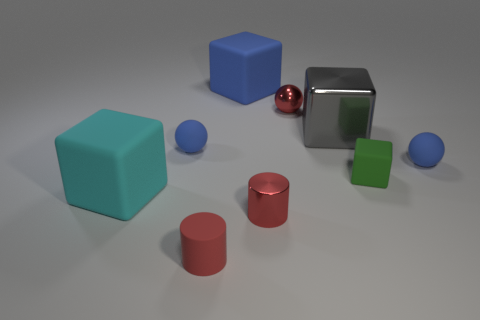Is there any other thing that has the same material as the tiny green cube?
Provide a short and direct response. Yes. There is a matte object that is the same color as the metal cylinder; what is its shape?
Give a very brief answer. Cylinder. There is a cyan thing that is the same material as the tiny cube; what is its size?
Give a very brief answer. Large. What number of tiny spheres are behind the blue rubber ball that is left of the small green rubber thing?
Offer a terse response. 1. Is there another thing of the same shape as the red rubber object?
Ensure brevity in your answer.  Yes. What is the color of the matte object to the left of the small thing left of the matte cylinder?
Your answer should be very brief. Cyan. Is the number of gray objects greater than the number of large rubber things?
Provide a succinct answer. No. What number of other green rubber objects are the same size as the green rubber object?
Ensure brevity in your answer.  0. Does the tiny block have the same material as the big blue block that is behind the small metal ball?
Provide a short and direct response. Yes. Is the number of gray metal things less than the number of tiny blue balls?
Your response must be concise. Yes. 